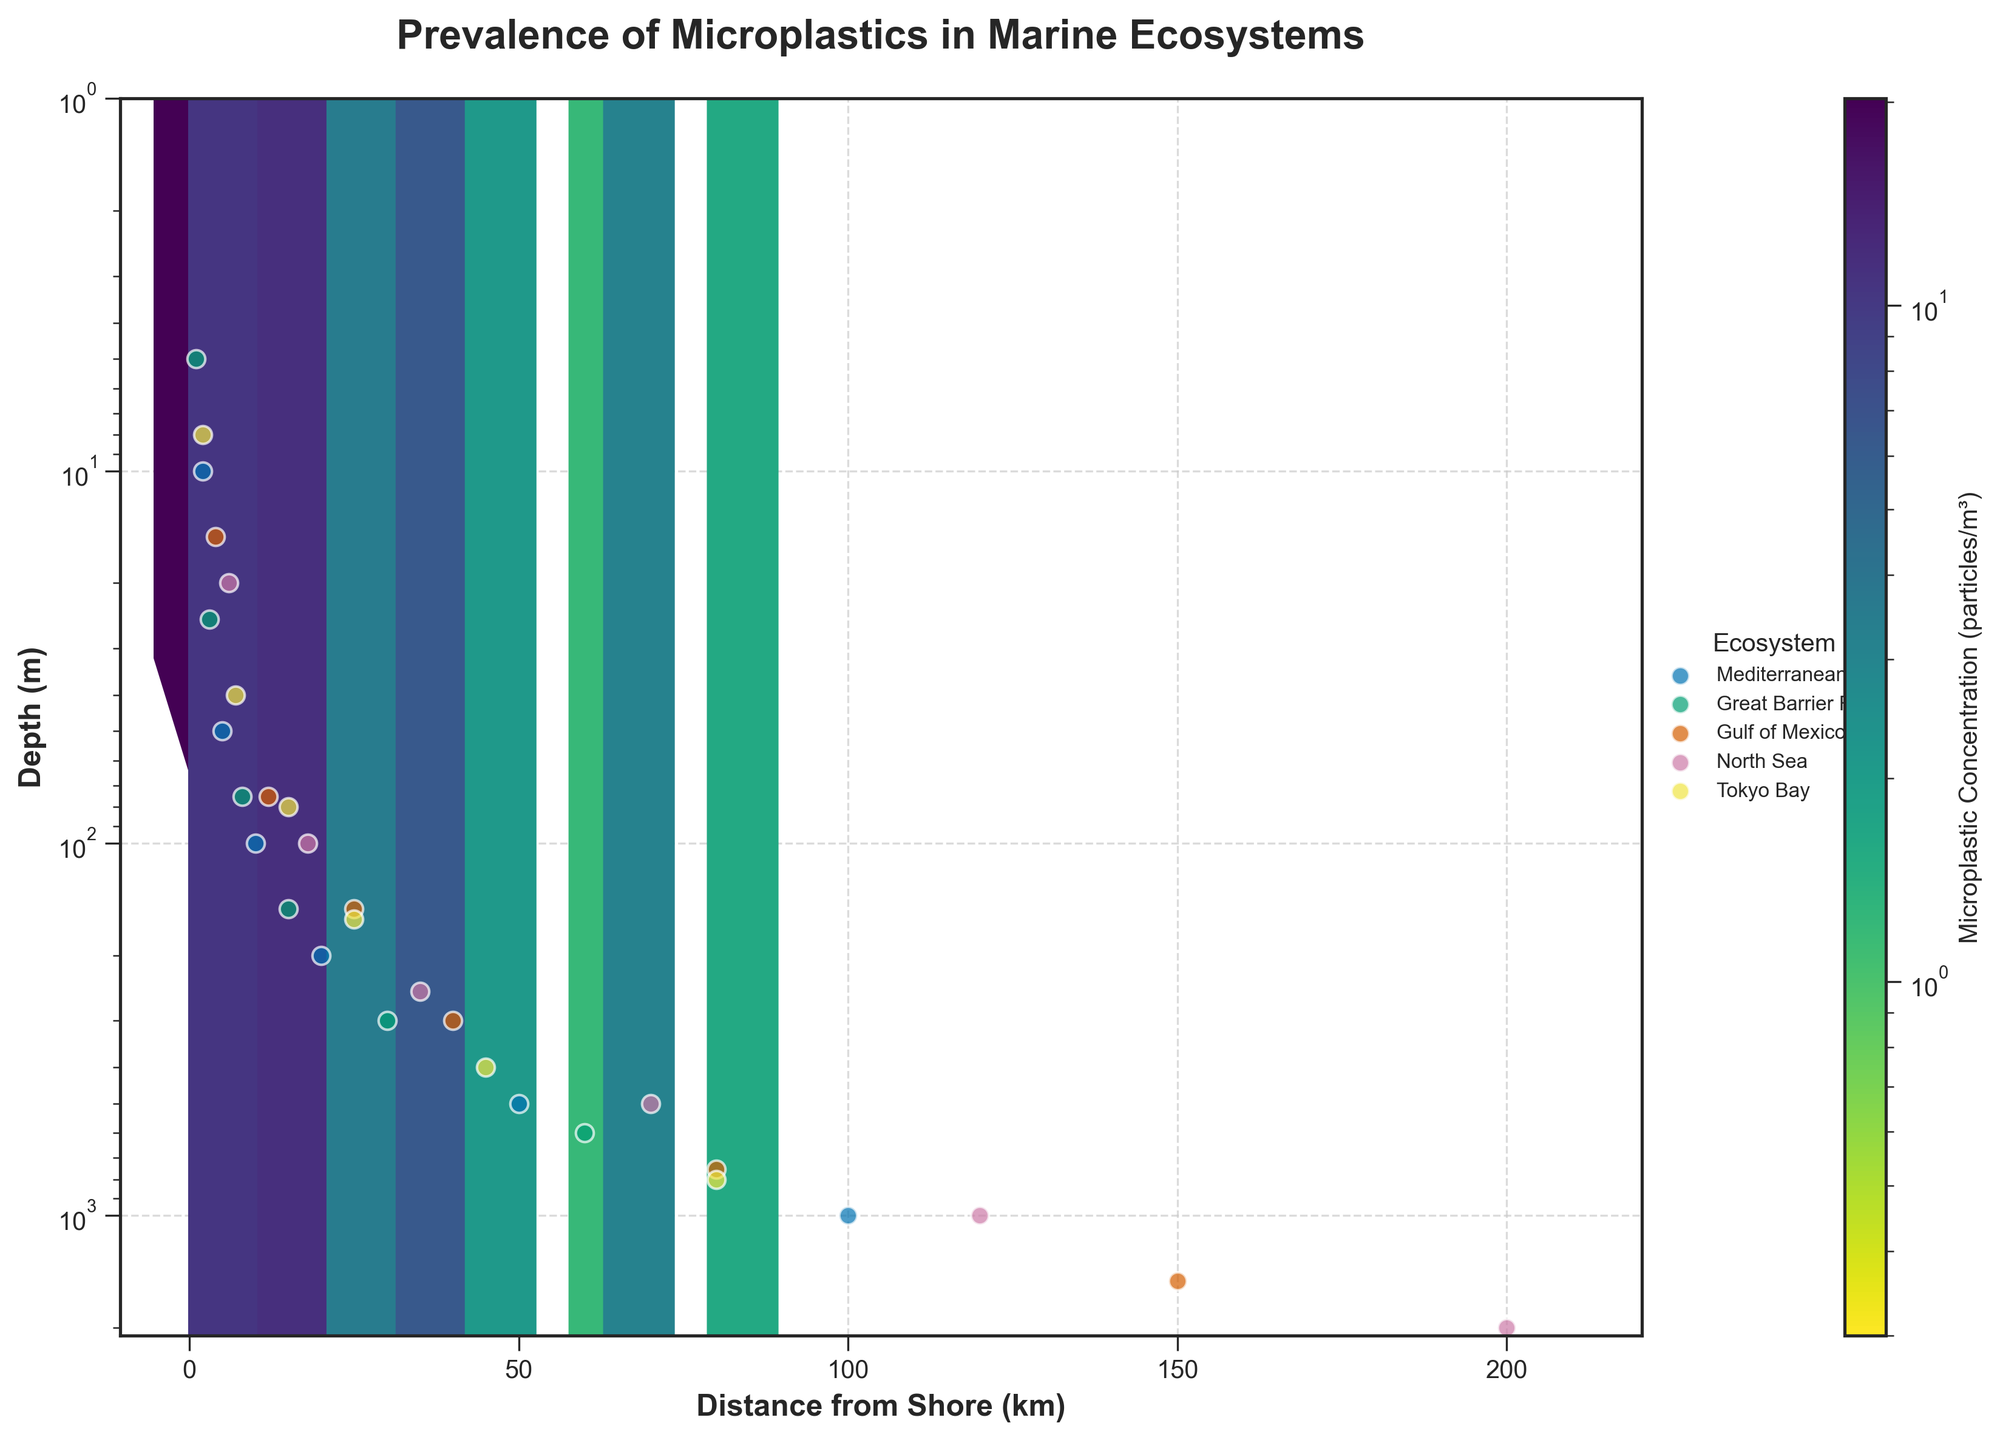What is the title of the plot? The title of the plot is typically placed at the top and should be read directly from the plot. Here, it is "Prevalence of Microplastics in Marine Ecosystems."
Answer: Prevalence of Microplastics in Marine Ecosystems What are the x-axis and y-axis labels? The x-axis and y-axis labels provide information about the variables being plotted. In this plot, the x-axis label is "Distance from Shore (km)" and the y-axis label is "Depth (m)."
Answer: Distance from Shore (km) and Depth (m) Which marine ecosystem shows the highest microplastic concentration near the shore? Microplastic concentration is shown using color intensity or size in a hexbin plot. By examining the figure, the highest concentration near the shore appears more intense in Tokyo Bay.
Answer: Tokyo Bay How does microplastic concentration change with increasing depth in the Mediterranean Sea? To answer this, examine the Mediterranean Sea's data points and their associated colors or values as the y-axis increases. Microplastic concentration decreases with increasing depth.
Answer: It decreases Which ecosystem shows microplastic concentrations at the greatest depths? To determine this, observe the scattering of data points corresponding to each ecosystem on the depth axis. The Gulf of Mexico and North Sea have points at the greatest depths.
Answer: Gulf of Mexico and North Sea Do shallow waters or deep waters generally show higher microplastic concentrations? This can be assessed by looking at the color or intensity of the hexagons for shallow versus deep waters. Shallower waters generally show higher concentrations.
Answer: Shallow waters Compare the microplastic concentration between Tokyo Bay and the Great Barrier Reef at similar distances from shore. By comparing the colors or values of Tokyo Bay’s and the Great Barrier Reef’s data points at similar distances, Tokyo Bay shows higher concentrations than the Great Barrier Reef at similar distances.
Answer: Tokyo Bay has higher concentrations What is the color scale used to represent microplastic concentration in the hexbin plot? The color scale representing microplastic concentration is usually shown in the color bar legend on the side. In this plot, it ranges from light to dark in the 'viridis_r' colormap.
Answer: Viridis_r colormap What log scale is used on the y-axis? The y-axis scale type can be deduced from the axis label and tick marks. This plot uses a logarithmic scale on the y-axis, indicated by the spacing of the ticks.
Answer: Logarithmic scale Which ecosystem has the highest variability in microplastic concentration by depth and distance from shore? To determine variability, examine the spread and color intensity of the data points for each ecosystem. Tokyo Bay appears to have the greatest range and variability in microplastic concentrations.
Answer: Tokyo Bay 